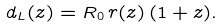Convert formula to latex. <formula><loc_0><loc_0><loc_500><loc_500>d _ { L } ( z ) = R _ { 0 } \, r ( z ) \, ( 1 + z ) .</formula> 